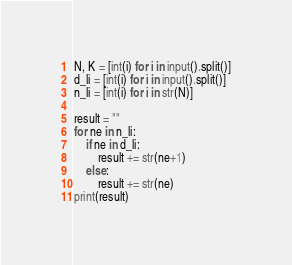<code> <loc_0><loc_0><loc_500><loc_500><_Python_>N, K = [int(i) for i in input().split()]
d_li = [int(i) for i in input().split()]
n_li = [int(i) for i in str(N)]

result = ""
for ne in n_li:
    if ne in d_li:
        result += str(ne+1)
    else:
        result += str(ne)
print(result)</code> 